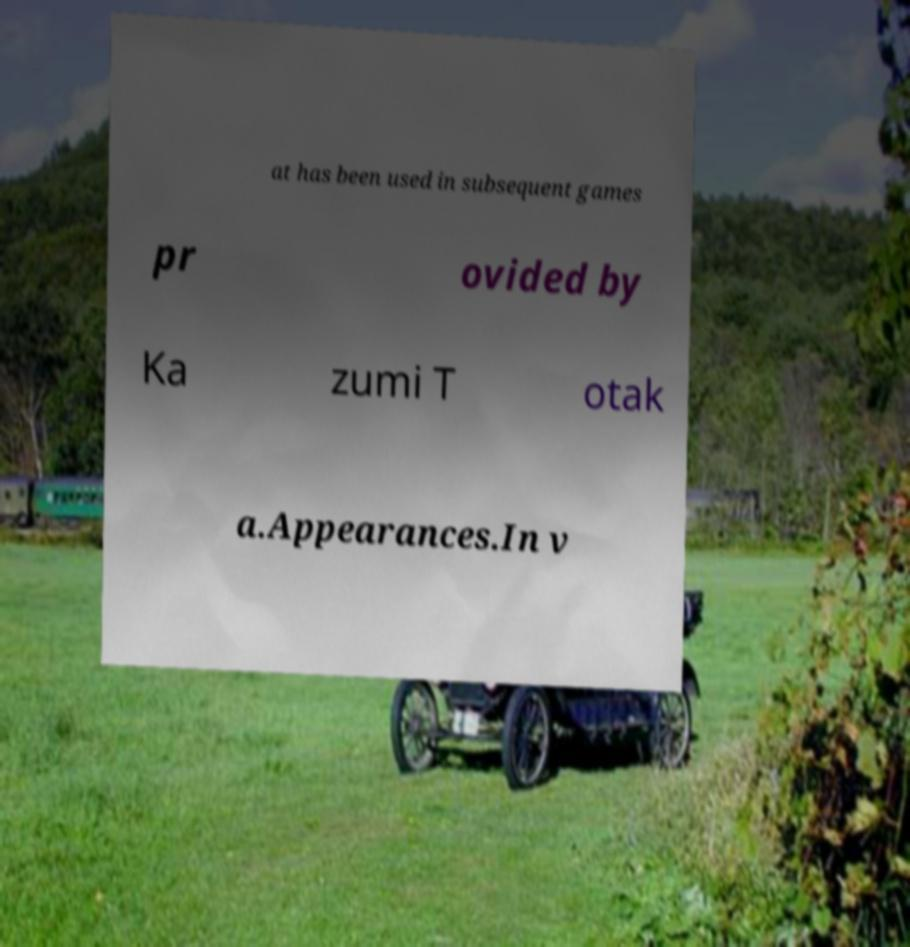For documentation purposes, I need the text within this image transcribed. Could you provide that? at has been used in subsequent games pr ovided by Ka zumi T otak a.Appearances.In v 